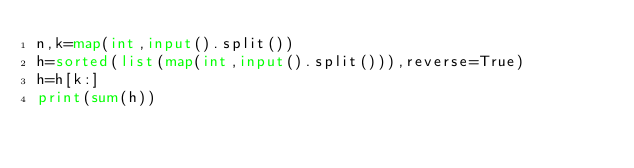<code> <loc_0><loc_0><loc_500><loc_500><_Python_>n,k=map(int,input().split())
h=sorted(list(map(int,input().split())),reverse=True)
h=h[k:]
print(sum(h))</code> 